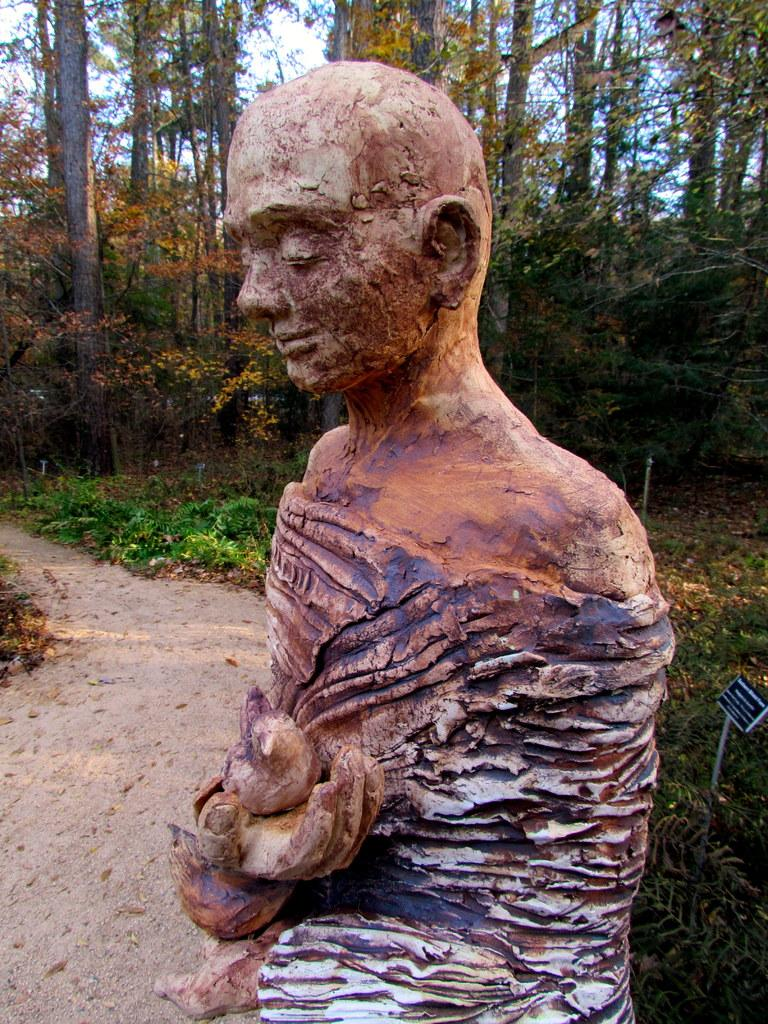What is the main subject of the image? There is a statue in the image. What is the statue depicting? The statue is of a person. What is the person in the statue doing? The person is holding a bird in their hand. What can be seen in the background of the image? There are trees in the background of the image. Where is the faucet located in the image? There is no faucet present in the image. Can you tell me what type of receipt the person in the statue is holding? The person in the statue is holding a bird, not a receipt. 